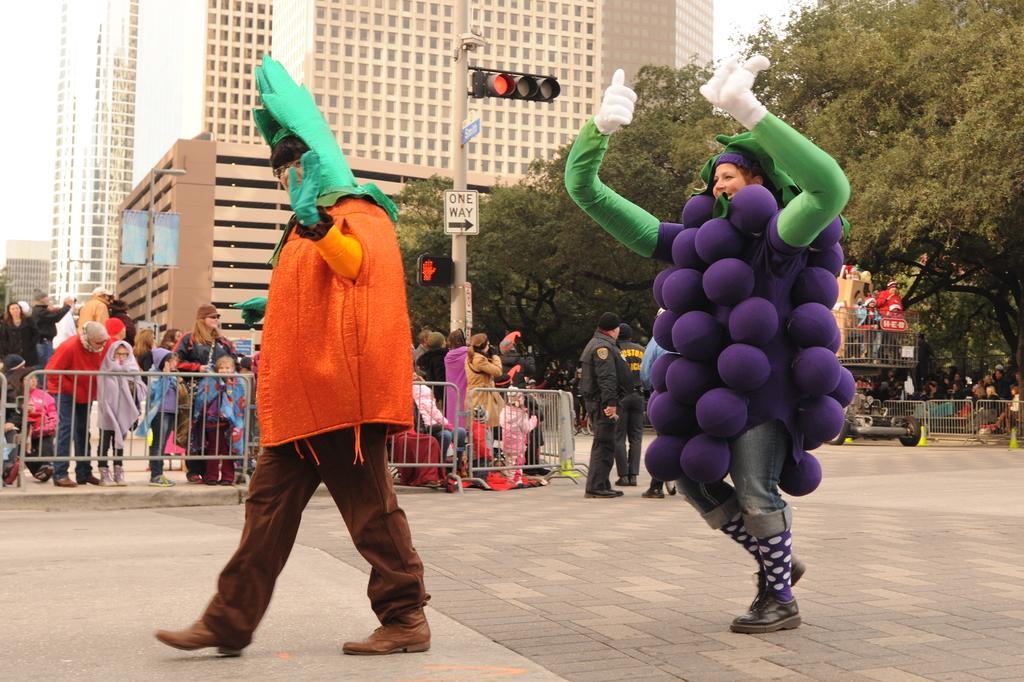How would you summarize this image in a sentence or two? This picture is clicked outside the city. In this picture, we see two people who are wearing the costumes are walking on the road. These costumes are in green, orange and purple color. In the middle, we see the road railing and people are standing beside the railing. Beside them, we see a pole and a traffic signal. Beside that, we see the two men in the uniform are standing. On the right side, we see the road railing and people are sitting. Beside that, we see the road stoppers and a vehicle. There are trees and buildings in the background. 